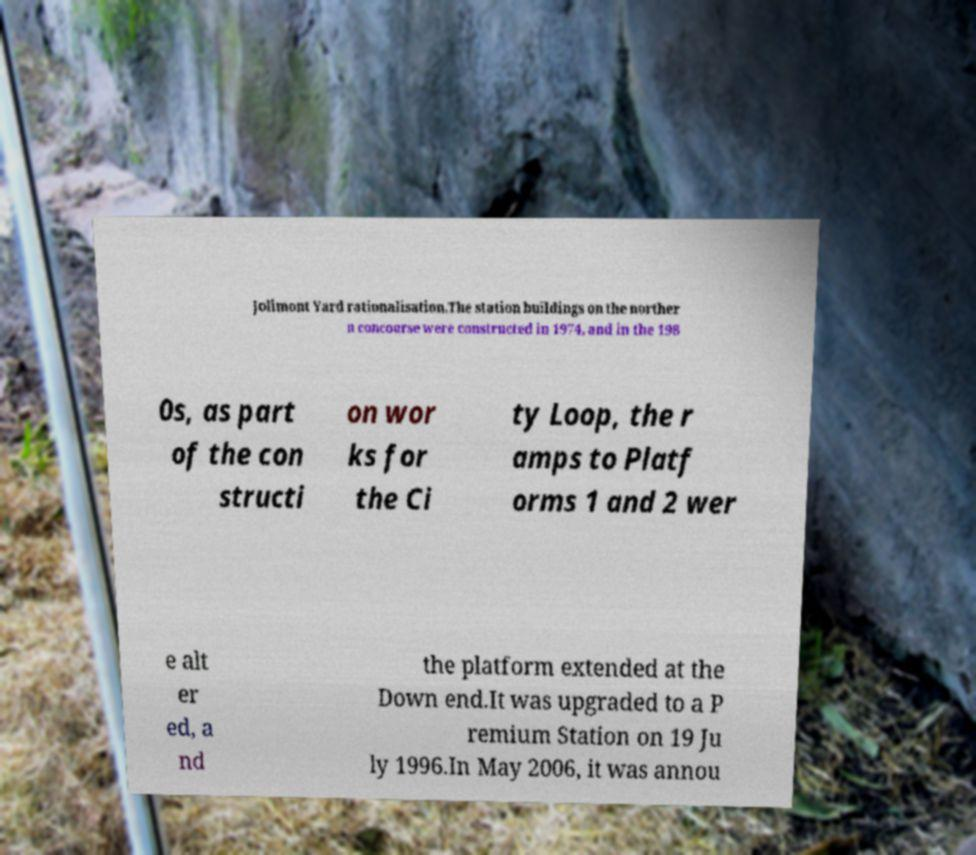I need the written content from this picture converted into text. Can you do that? Jolimont Yard rationalisation.The station buildings on the norther n concourse were constructed in 1974, and in the 198 0s, as part of the con structi on wor ks for the Ci ty Loop, the r amps to Platf orms 1 and 2 wer e alt er ed, a nd the platform extended at the Down end.It was upgraded to a P remium Station on 19 Ju ly 1996.In May 2006, it was annou 